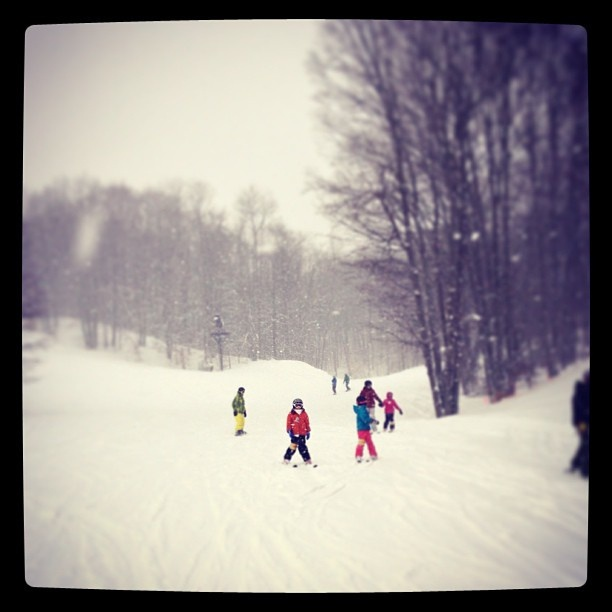Describe the objects in this image and their specific colors. I can see people in black, navy, gray, and darkgray tones, people in black, lightgray, brown, and navy tones, people in black, teal, brown, and blue tones, people in black, gray, khaki, and darkgray tones, and people in black, purple, darkgray, and navy tones in this image. 